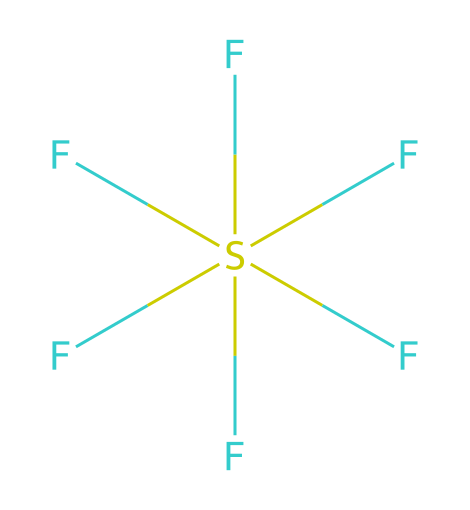How many fluorine atoms are present in sulfur hexafluoride? The SMILES representation shows six fluorine atoms (F) connected to the sulfur atom (S), indicating that there are six fluorine atoms in total.
Answer: six What is the central atom in this chemical structure? The SMILES representation indicates that sulfur (S) is at the center, surrounded by fluorine atoms, making it the central atom.
Answer: sulfur How many total bonds are formed in sulfur hexafluoride? Each fluorine forms a single bond with the sulfur atom. Since there are six fluorine atoms, there are six bonds in total.
Answer: six What type of hybridization is expected for the sulfur atom in SF6? The sulfur atom in SF6 is surrounded by six bonding pairs of electrons with no lone pairs, resulting in an octahedral geometry and sp3d2 hybridization.
Answer: sp3d2 Is sulfur hexafluoride a polar or nonpolar molecule? Due to its symmetrical arrangement of six polar bonds around the sulfur atom, the dipoles cancel out, making SF6 a nonpolar molecule.
Answer: nonpolar What makes sulfur hexafluoride a hypervalent compound? A hypervalent compound can have more than four bonds around a central atom. In SF6, sulfur forms six bonds with fluorine, exceeding the octet rule, which defines it as hypervalent.
Answer: hypervalent What is the primary use of sulfur hexafluoride in industry? SF6 is primarily used in electrical insulation in high-voltage equipment due to its excellent dielectric properties.
Answer: electrical insulation 